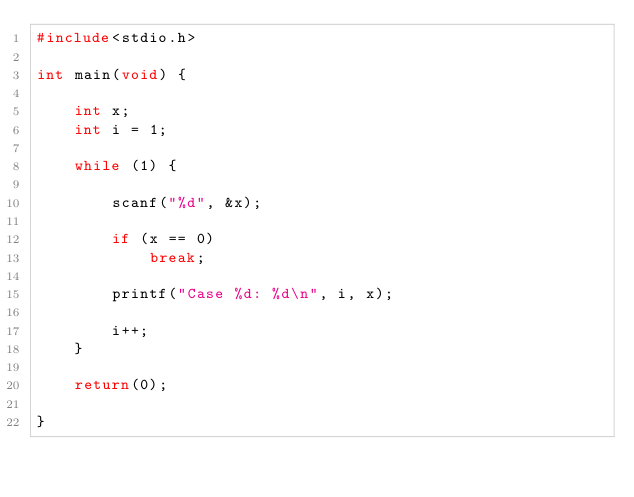<code> <loc_0><loc_0><loc_500><loc_500><_C_>#include<stdio.h>

int main(void) {

	int x;
	int i = 1;

	while (1) {

		scanf("%d", &x);

		if (x == 0)
			break;

		printf("Case %d: %d\n", i, x);

		i++;
	}

	return(0);

}
</code> 